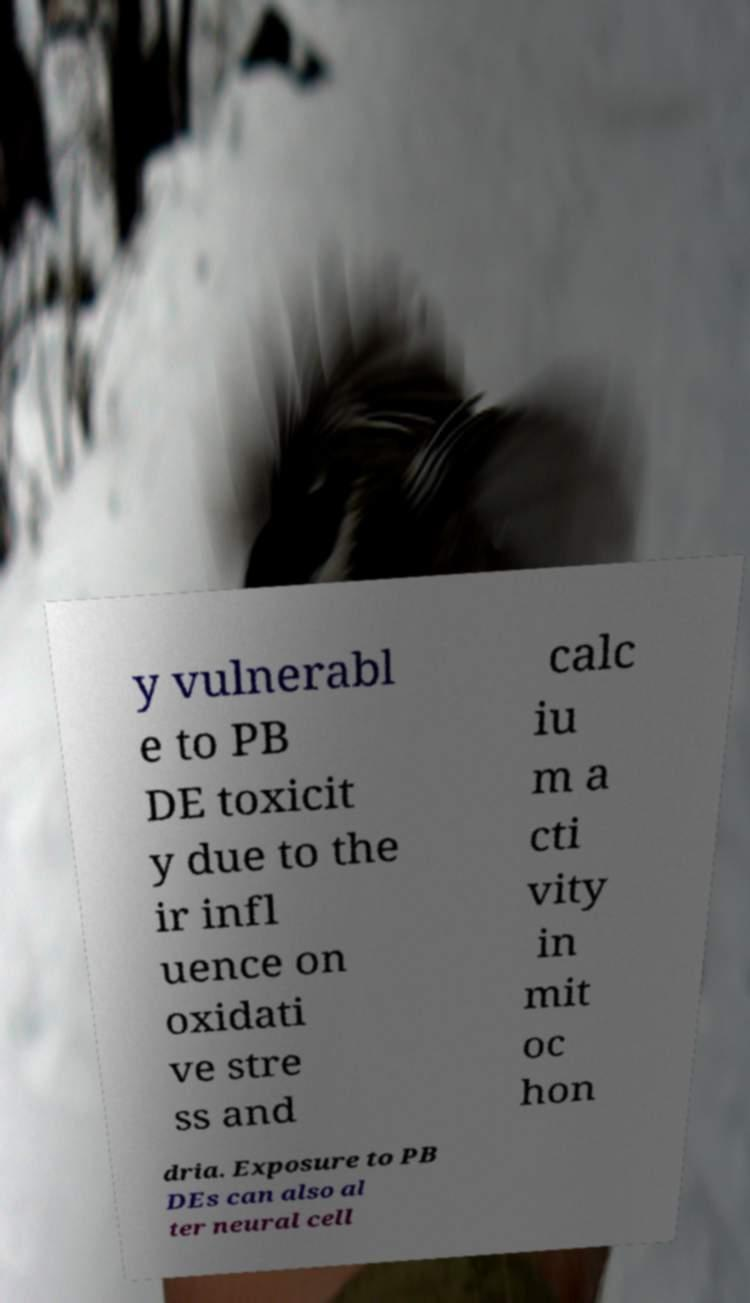Can you read and provide the text displayed in the image?This photo seems to have some interesting text. Can you extract and type it out for me? y vulnerabl e to PB DE toxicit y due to the ir infl uence on oxidati ve stre ss and calc iu m a cti vity in mit oc hon dria. Exposure to PB DEs can also al ter neural cell 